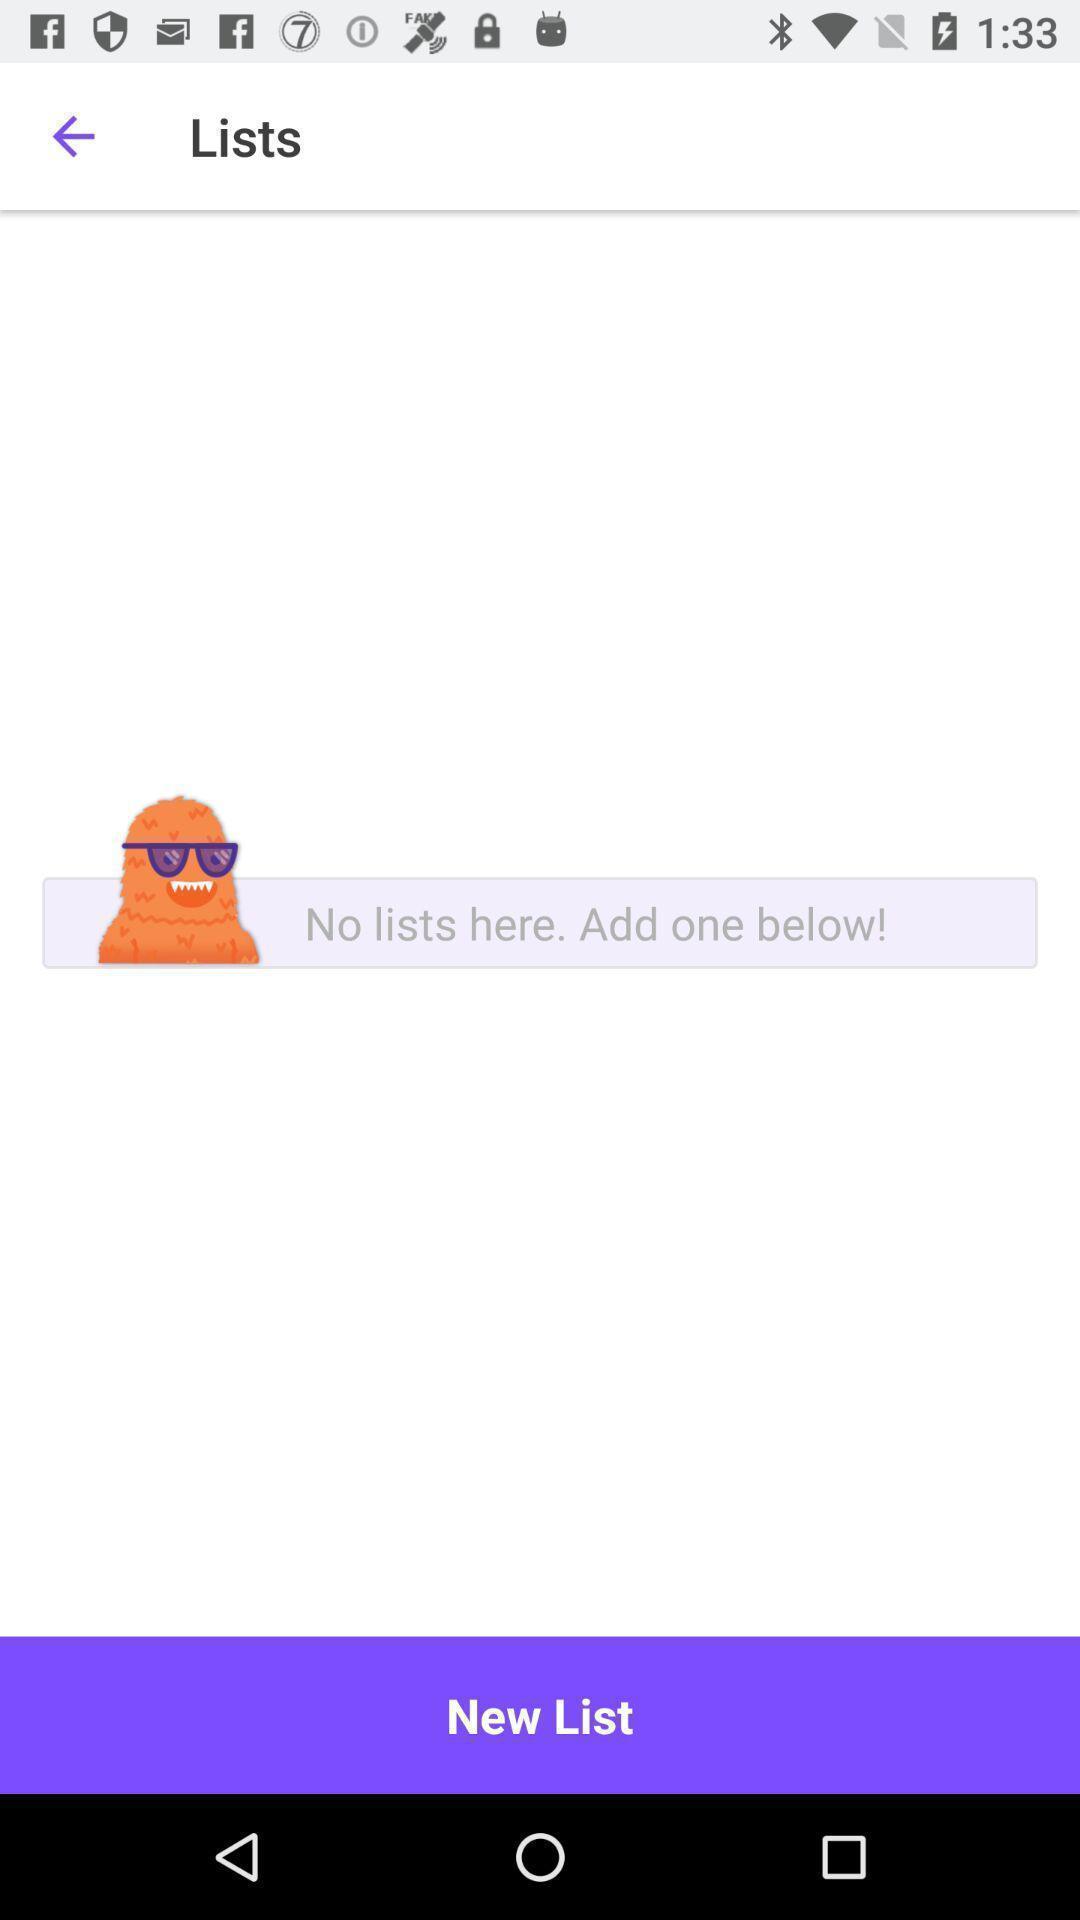Tell me about the visual elements in this screen capture. Screen showing blank list of social app. 